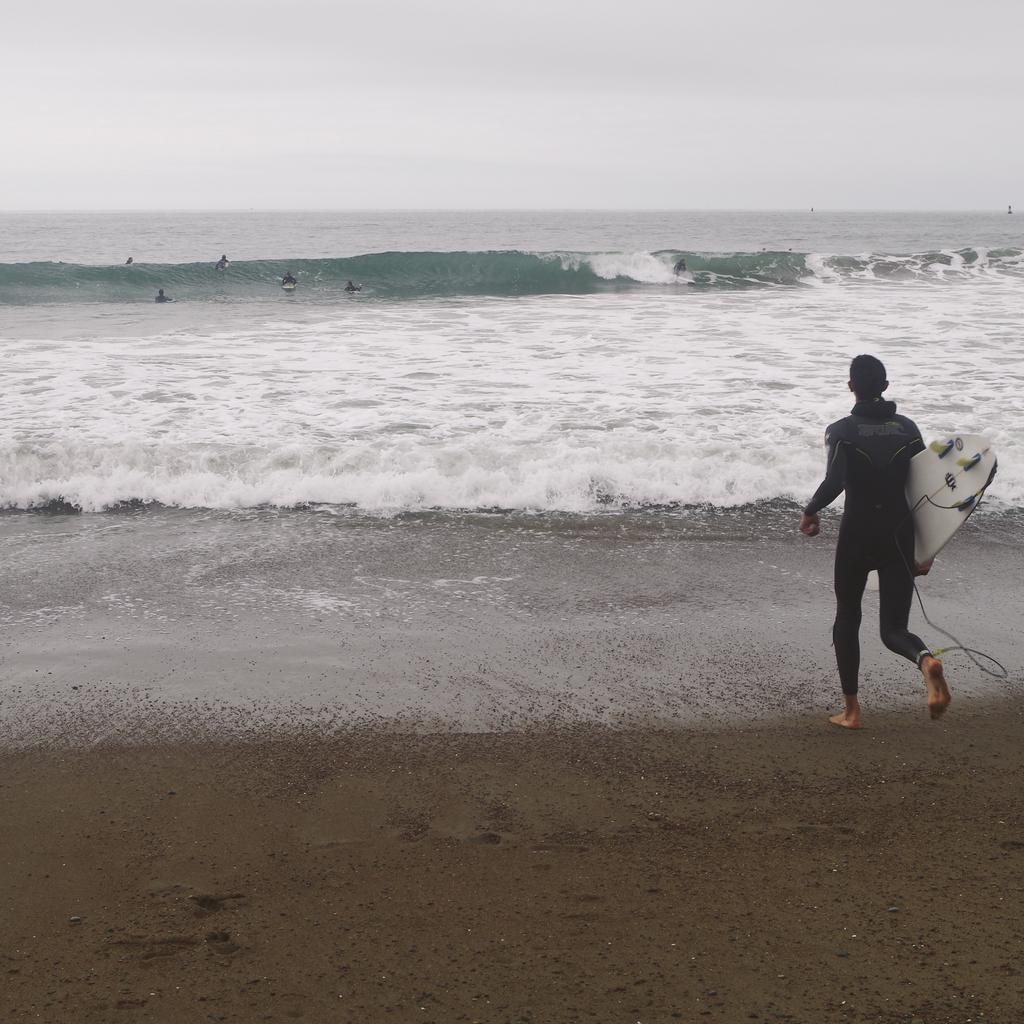What is the main subject of the image? The main subject of the image is a woman. What is the woman holding in the image? The woman is holding a surfing board. What is the setting of the image? The image is of the sea. What shape is the woman's teeth in the image? There is no information about the woman's teeth in the image, so we cannot determine their shape. 